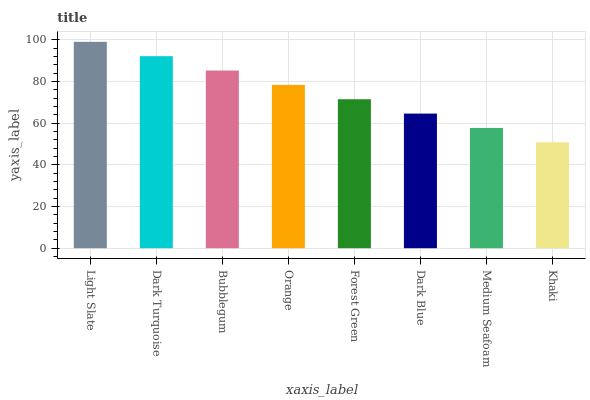Is Khaki the minimum?
Answer yes or no. Yes. Is Light Slate the maximum?
Answer yes or no. Yes. Is Dark Turquoise the minimum?
Answer yes or no. No. Is Dark Turquoise the maximum?
Answer yes or no. No. Is Light Slate greater than Dark Turquoise?
Answer yes or no. Yes. Is Dark Turquoise less than Light Slate?
Answer yes or no. Yes. Is Dark Turquoise greater than Light Slate?
Answer yes or no. No. Is Light Slate less than Dark Turquoise?
Answer yes or no. No. Is Orange the high median?
Answer yes or no. Yes. Is Forest Green the low median?
Answer yes or no. Yes. Is Light Slate the high median?
Answer yes or no. No. Is Light Slate the low median?
Answer yes or no. No. 